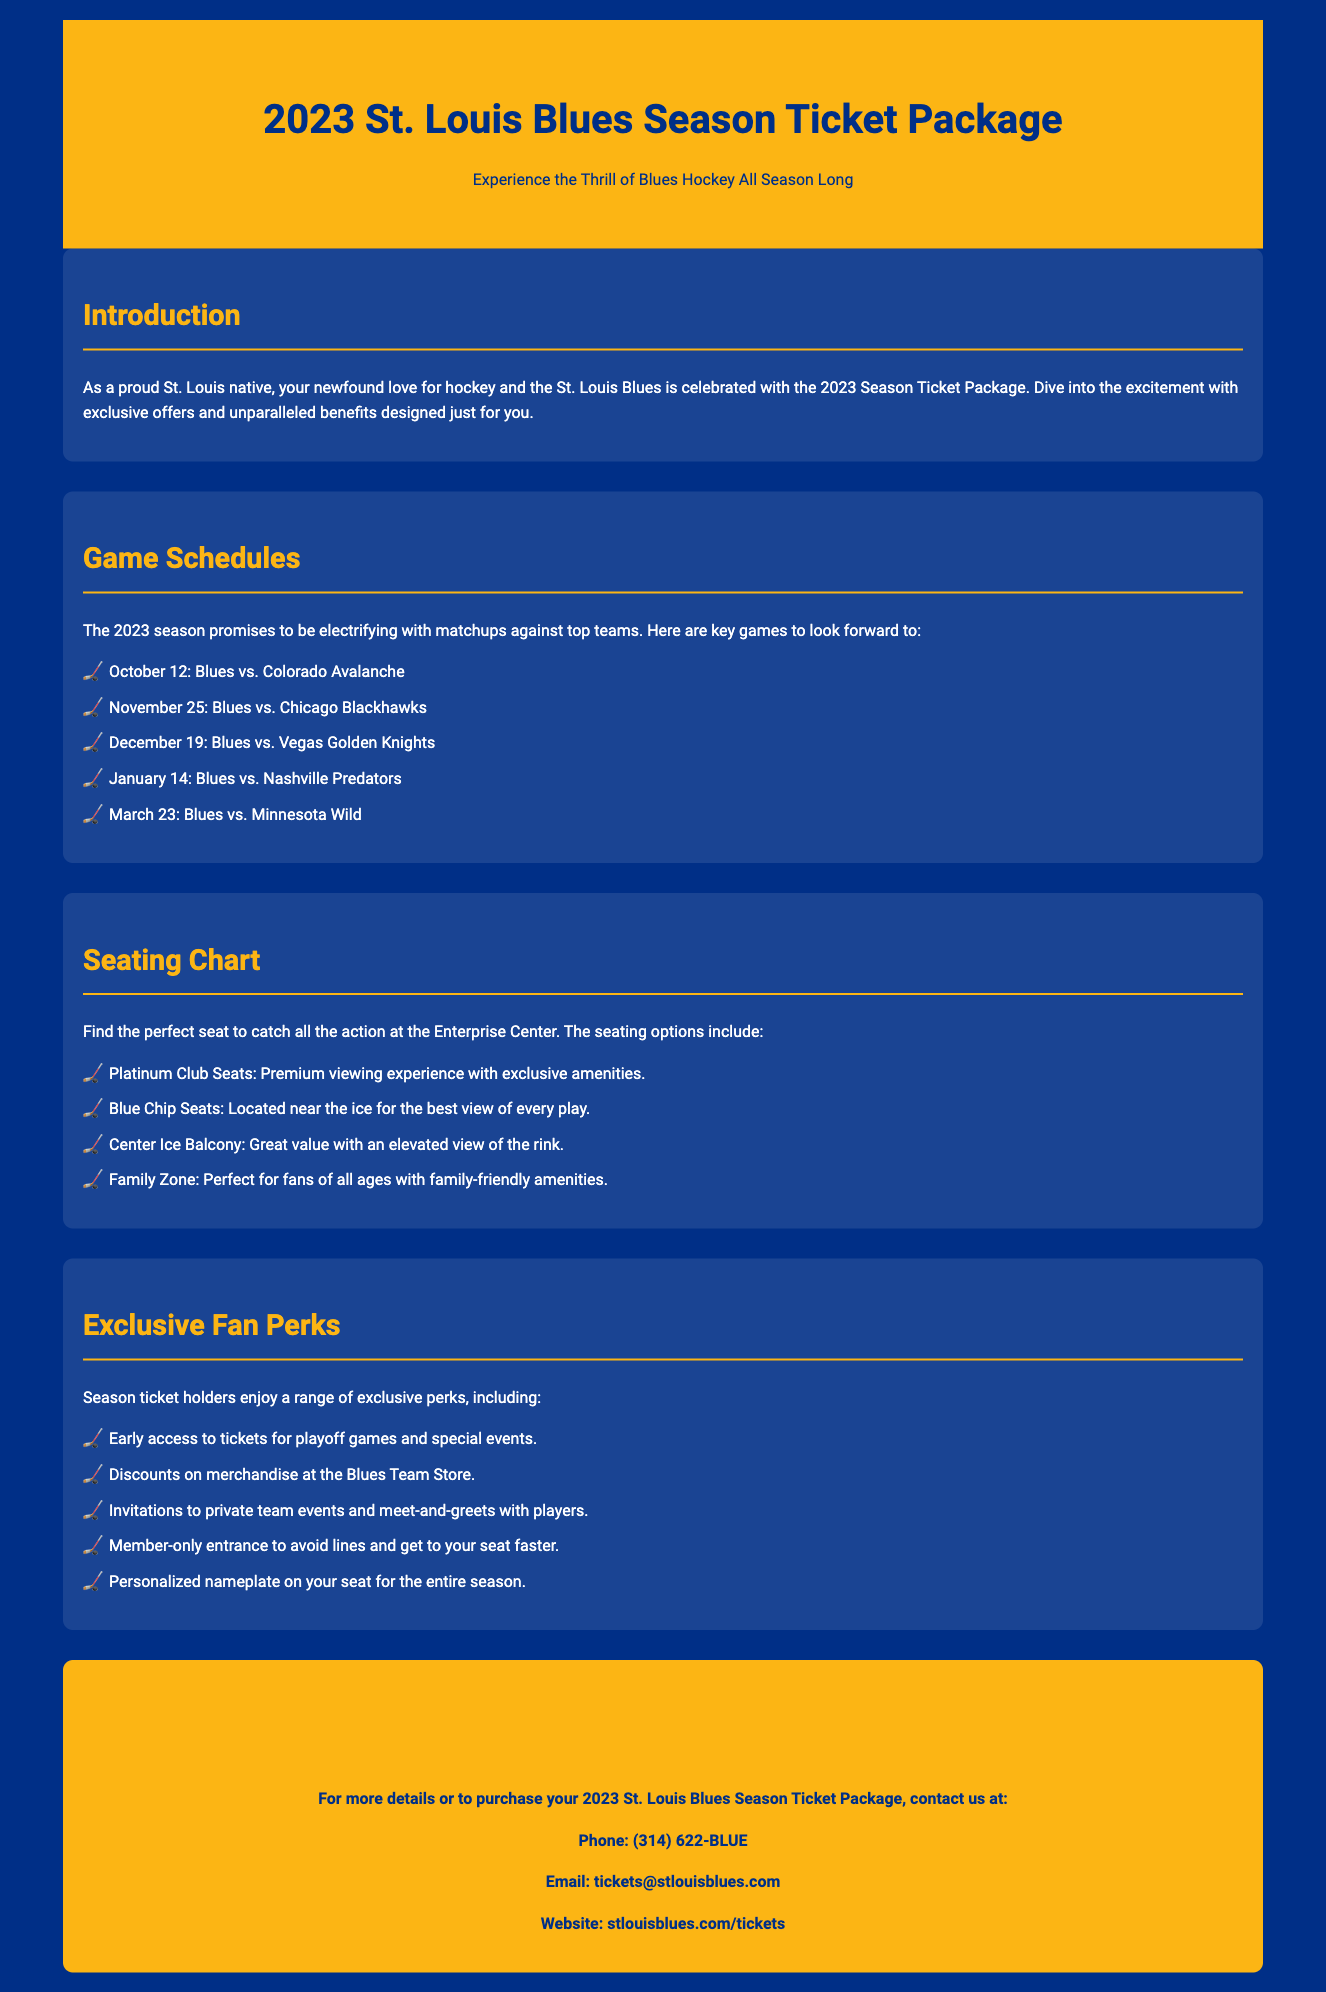What is the first game of the season? The first game of the season is listed in the document as October 12 against the Colorado Avalanche.
Answer: October 12 What seating option offers premium viewing experience? The document specifies Platinum Club Seats as those that provide a premium viewing experience with exclusive amenities.
Answer: Platinum Club Seats Which team do the Blues play on November 25? The document mentions the matchup against the Chicago Blackhawks on November 25.
Answer: Chicago Blackhawks How many exclusive fan perks are listed? The document lists five exclusive fan perks available to season ticket holders.
Answer: Five What is the contact phone number for ticket information? The document contains the phone number (314) 622-BLUE for contacting ticket information.
Answer: (314) 622-BLUE Which seating area is perfect for families? The Family Zone is identified in the document as the seating area perfect for fans of all ages.
Answer: Family Zone What discount benefit do season ticket holders receive? According to the document, season ticket holders receive discounts on merchandise at the Blues Team Store.
Answer: Discounts on merchandise When is the game against the Vegas Golden Knights? The document states that the game against the Vegas Golden Knights is scheduled for December 19.
Answer: December 19 